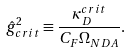<formula> <loc_0><loc_0><loc_500><loc_500>\hat { g } _ { c r i t } ^ { 2 } \equiv \frac { \kappa _ { D } ^ { c r i t } } { C _ { F } \Omega _ { N D A } } .</formula> 